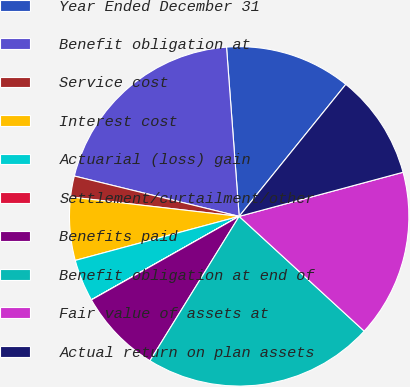<chart> <loc_0><loc_0><loc_500><loc_500><pie_chart><fcel>Year Ended December 31<fcel>Benefit obligation at<fcel>Service cost<fcel>Interest cost<fcel>Actuarial (loss) gain<fcel>Settlement/curtailment/other<fcel>Benefits paid<fcel>Benefit obligation at end of<fcel>Fair value of assets at<fcel>Actual return on plan assets<nl><fcel>12.0%<fcel>19.99%<fcel>2.0%<fcel>6.0%<fcel>4.0%<fcel>0.01%<fcel>8.0%<fcel>21.99%<fcel>16.0%<fcel>10.0%<nl></chart> 